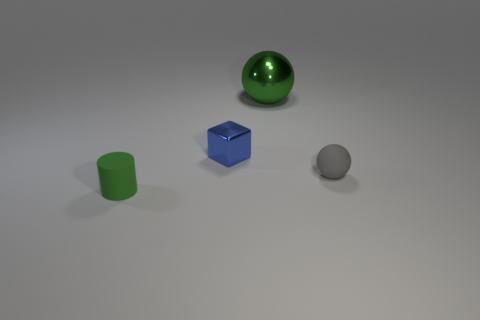What number of green objects are both left of the blue shiny thing and behind the green matte cylinder?
Give a very brief answer. 0. What number of purple things are large metallic balls or small balls?
Provide a succinct answer. 0. Does the rubber thing that is right of the blue block have the same color as the matte thing left of the small matte sphere?
Keep it short and to the point. No. There is a tiny matte thing behind the green object that is in front of the ball on the left side of the small ball; what is its color?
Keep it short and to the point. Gray. There is a small matte thing behind the tiny cylinder; are there any green things on the right side of it?
Offer a terse response. No. There is a tiny rubber thing that is on the right side of the green matte cylinder; is its shape the same as the tiny blue thing?
Keep it short and to the point. No. Is there anything else that is the same shape as the blue shiny object?
Your response must be concise. No. How many cylinders are either tiny green rubber things or big objects?
Provide a succinct answer. 1. What number of big shiny cylinders are there?
Keep it short and to the point. 0. There is a green thing in front of the matte object to the right of the big shiny sphere; how big is it?
Provide a short and direct response. Small. 